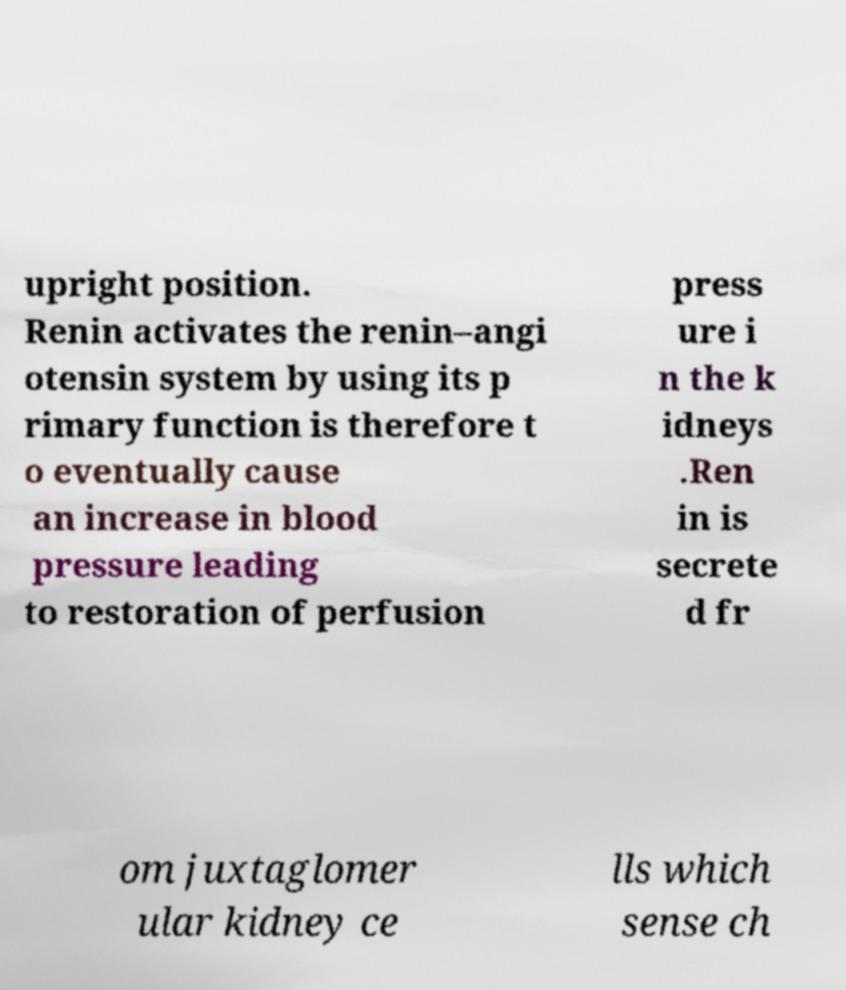For documentation purposes, I need the text within this image transcribed. Could you provide that? upright position. Renin activates the renin–angi otensin system by using its p rimary function is therefore t o eventually cause an increase in blood pressure leading to restoration of perfusion press ure i n the k idneys .Ren in is secrete d fr om juxtaglomer ular kidney ce lls which sense ch 